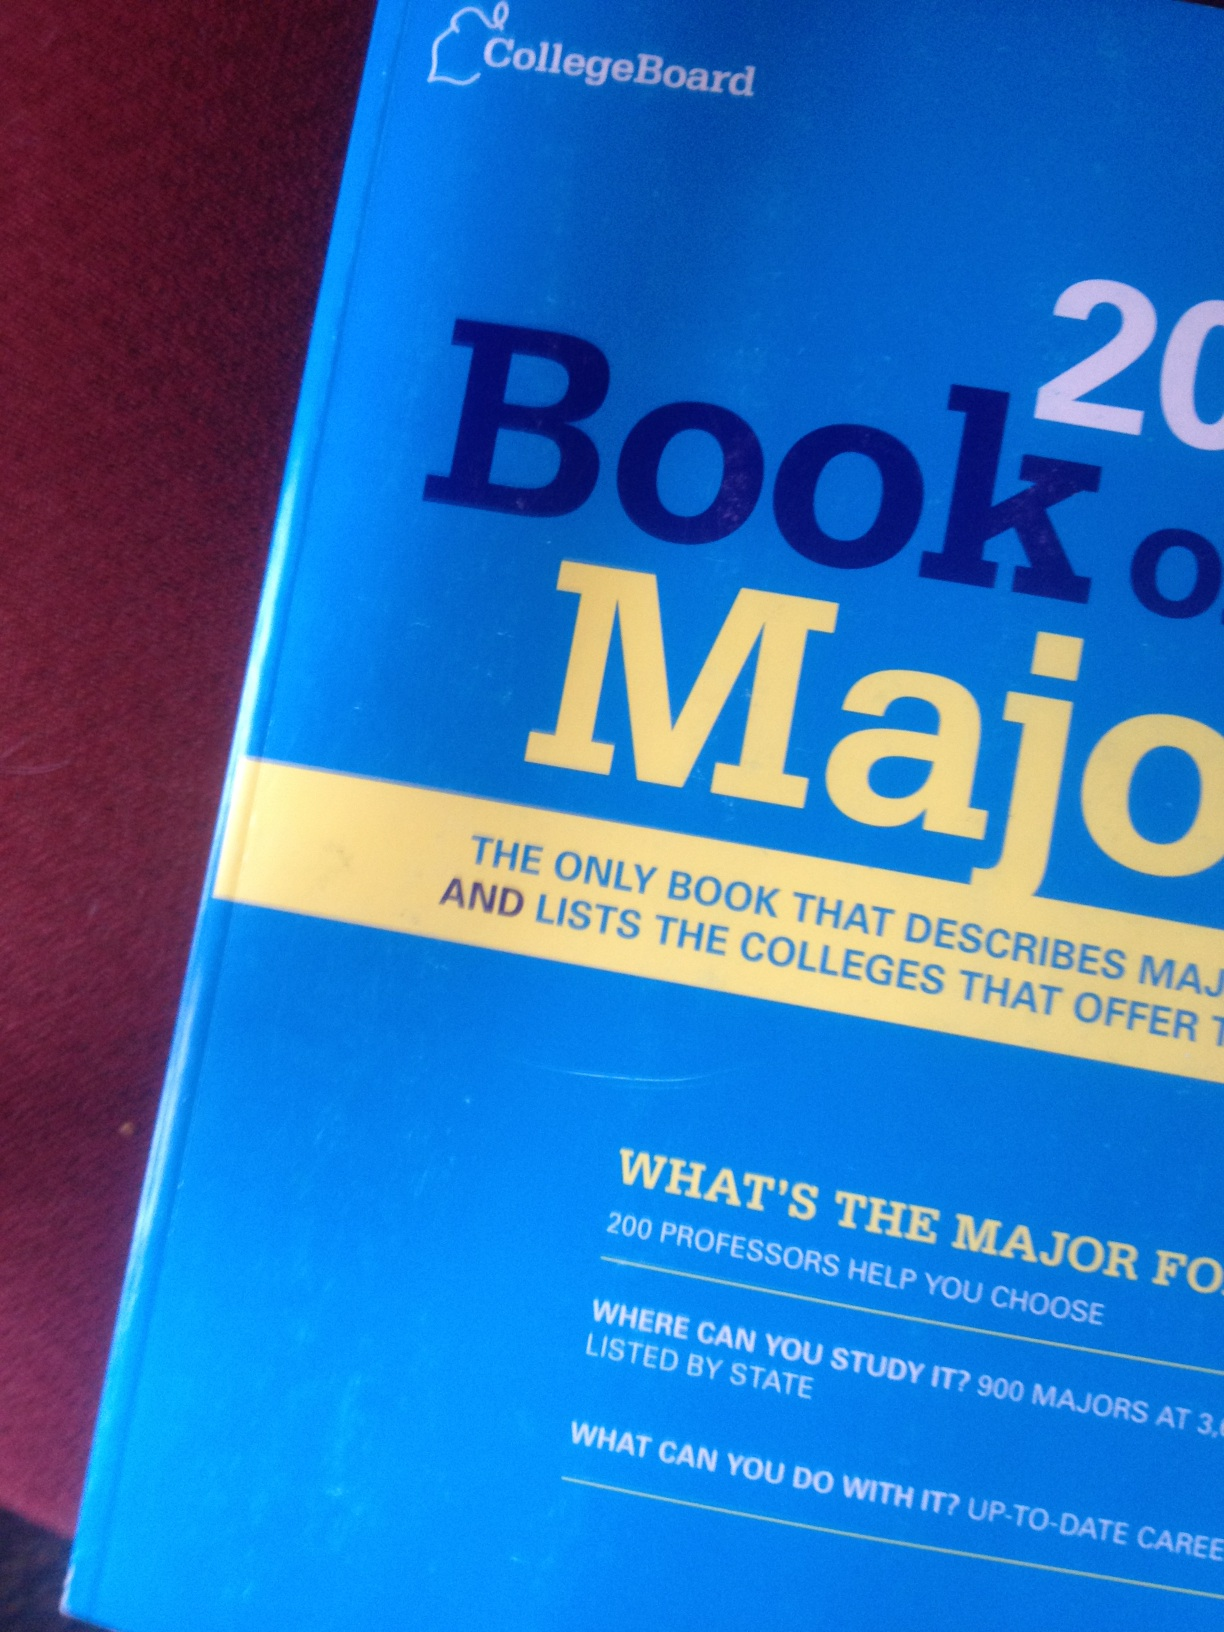Can you tell me more about what this book offers? Sure! The 'Book of Majors 2014' by CollegeBoard is a detailed guide for students exploring their academic and career paths. It includes descriptions of various majors, insights from 200 professors, and a comprehensive list of colleges offering these majors. Additionally, it provides state-wide listings and up-to-date career information based on the chosen majors. How would you use this book if you were a high school student? As a high school student, I would use the 'Book of Majors 2014' to explore different academic fields and understand which majors align with my interests and strengths. By reading the insights from professors and reviewing the colleges offering the majors I am interested in, I would make more informed decisions about where to apply and what to study, ultimately helping to prepare for my future career. 